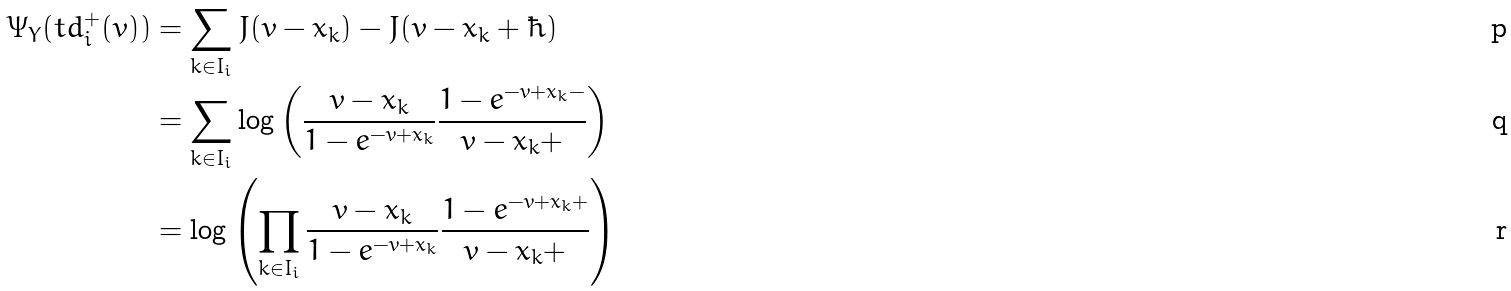Convert formula to latex. <formula><loc_0><loc_0><loc_500><loc_500>\Psi _ { Y } ( t d ^ { + } _ { i } ( v ) ) & = \sum _ { k \in I _ { i } } J ( v - x _ { k } ) - J ( v - x _ { k } + \hbar { ) } \\ & = \sum _ { k \in I _ { i } } \log \left ( \frac { v - x _ { k } } { 1 - e ^ { - v + x _ { k } } } \frac { 1 - e ^ { - v + x _ { k } - } } { v - x _ { k } + } \right ) \\ & = \log \left ( \prod _ { k \in I _ { i } } \frac { v - x _ { k } } { 1 - e ^ { - v + x _ { k } } } \frac { 1 - e ^ { - v + x _ { k } + } } { v - x _ { k } + } \right )</formula> 